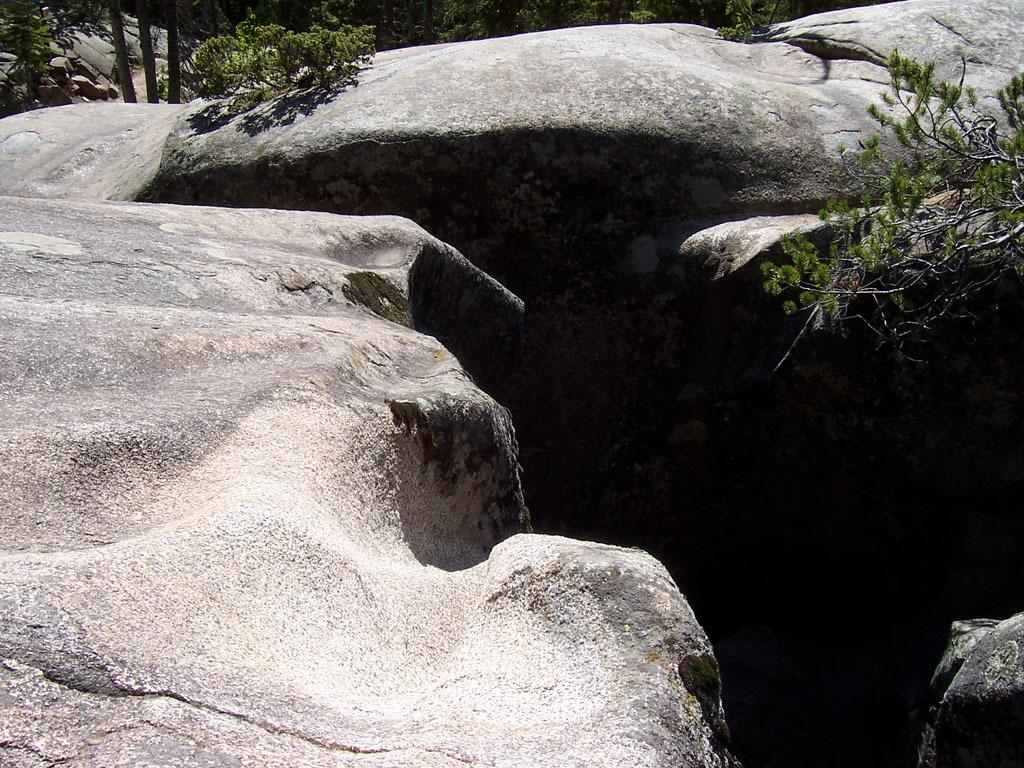What type of natural elements can be seen in the image? There are rocks in the image. Where are the plants located in the image? There are plants on the right side and left side of the image, as well as in the background. What song is being sung by the robin in the image? There is no robin present in the image, and therefore no song can be heard. 